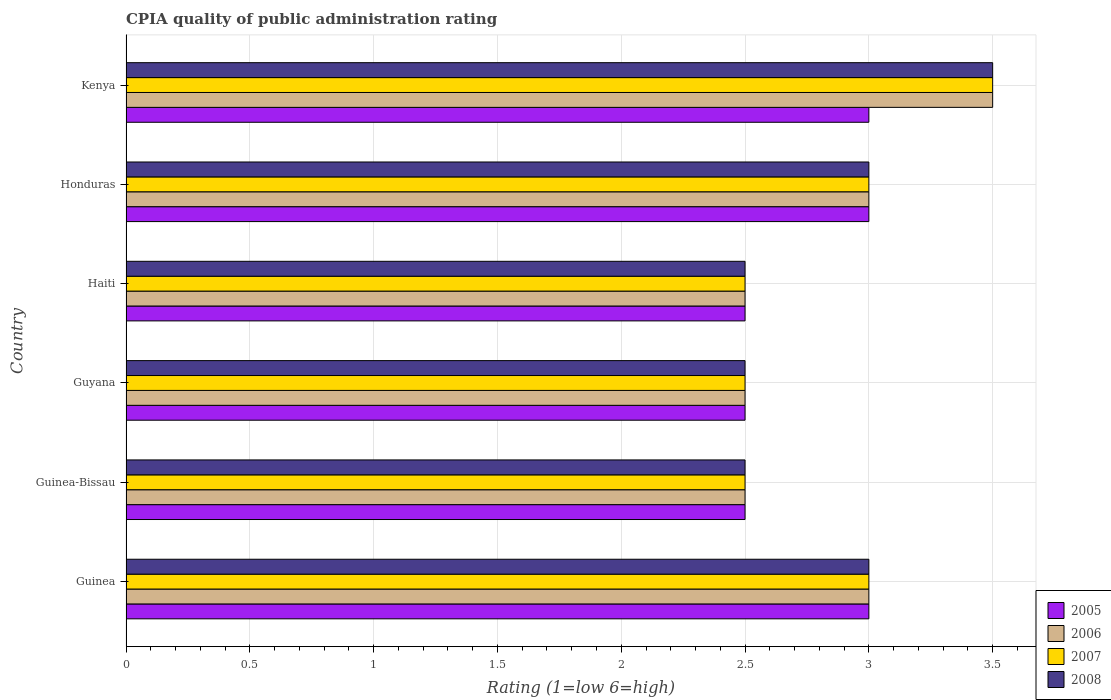How many different coloured bars are there?
Your response must be concise. 4. Are the number of bars per tick equal to the number of legend labels?
Give a very brief answer. Yes. Are the number of bars on each tick of the Y-axis equal?
Your answer should be very brief. Yes. How many bars are there on the 6th tick from the top?
Provide a short and direct response. 4. How many bars are there on the 2nd tick from the bottom?
Your answer should be very brief. 4. What is the label of the 4th group of bars from the top?
Your answer should be very brief. Guyana. In how many cases, is the number of bars for a given country not equal to the number of legend labels?
Your answer should be very brief. 0. What is the CPIA rating in 2007 in Guyana?
Ensure brevity in your answer.  2.5. Across all countries, what is the maximum CPIA rating in 2005?
Offer a very short reply. 3. Across all countries, what is the minimum CPIA rating in 2008?
Ensure brevity in your answer.  2.5. In which country was the CPIA rating in 2005 maximum?
Give a very brief answer. Guinea. In which country was the CPIA rating in 2005 minimum?
Keep it short and to the point. Guinea-Bissau. What is the difference between the CPIA rating in 2007 in Guinea-Bissau and that in Kenya?
Your answer should be compact. -1. What is the average CPIA rating in 2005 per country?
Your answer should be very brief. 2.75. In how many countries, is the CPIA rating in 2007 greater than 0.8 ?
Ensure brevity in your answer.  6. What is the ratio of the CPIA rating in 2008 in Guinea-Bissau to that in Guyana?
Offer a terse response. 1. Is the difference between the CPIA rating in 2005 in Guinea and Haiti greater than the difference between the CPIA rating in 2008 in Guinea and Haiti?
Keep it short and to the point. No. What is the difference between the highest and the lowest CPIA rating in 2008?
Your answer should be compact. 1. In how many countries, is the CPIA rating in 2007 greater than the average CPIA rating in 2007 taken over all countries?
Ensure brevity in your answer.  3. Is the sum of the CPIA rating in 2006 in Guinea and Guyana greater than the maximum CPIA rating in 2008 across all countries?
Offer a terse response. Yes. What does the 2nd bar from the top in Guinea-Bissau represents?
Your answer should be very brief. 2007. What does the 3rd bar from the bottom in Guyana represents?
Your response must be concise. 2007. How many bars are there?
Give a very brief answer. 24. What is the difference between two consecutive major ticks on the X-axis?
Ensure brevity in your answer.  0.5. Are the values on the major ticks of X-axis written in scientific E-notation?
Make the answer very short. No. Does the graph contain any zero values?
Offer a very short reply. No. Does the graph contain grids?
Your response must be concise. Yes. Where does the legend appear in the graph?
Ensure brevity in your answer.  Bottom right. How many legend labels are there?
Offer a terse response. 4. How are the legend labels stacked?
Your answer should be very brief. Vertical. What is the title of the graph?
Offer a very short reply. CPIA quality of public administration rating. Does "1992" appear as one of the legend labels in the graph?
Provide a succinct answer. No. What is the label or title of the X-axis?
Ensure brevity in your answer.  Rating (1=low 6=high). What is the Rating (1=low 6=high) in 2005 in Guinea?
Ensure brevity in your answer.  3. What is the Rating (1=low 6=high) of 2006 in Guinea?
Offer a terse response. 3. What is the Rating (1=low 6=high) of 2008 in Guinea?
Your answer should be compact. 3. What is the Rating (1=low 6=high) of 2005 in Guinea-Bissau?
Offer a very short reply. 2.5. What is the Rating (1=low 6=high) in 2006 in Guyana?
Your answer should be very brief. 2.5. What is the Rating (1=low 6=high) of 2007 in Guyana?
Ensure brevity in your answer.  2.5. What is the Rating (1=low 6=high) in 2006 in Haiti?
Your response must be concise. 2.5. What is the Rating (1=low 6=high) in 2007 in Haiti?
Give a very brief answer. 2.5. What is the Rating (1=low 6=high) of 2008 in Haiti?
Ensure brevity in your answer.  2.5. What is the Rating (1=low 6=high) of 2007 in Honduras?
Make the answer very short. 3. What is the Rating (1=low 6=high) of 2008 in Honduras?
Offer a very short reply. 3. What is the Rating (1=low 6=high) in 2005 in Kenya?
Provide a short and direct response. 3. What is the Rating (1=low 6=high) of 2006 in Kenya?
Your response must be concise. 3.5. Across all countries, what is the maximum Rating (1=low 6=high) of 2005?
Keep it short and to the point. 3. Across all countries, what is the maximum Rating (1=low 6=high) of 2006?
Your response must be concise. 3.5. Across all countries, what is the maximum Rating (1=low 6=high) in 2008?
Your response must be concise. 3.5. Across all countries, what is the minimum Rating (1=low 6=high) of 2007?
Make the answer very short. 2.5. Across all countries, what is the minimum Rating (1=low 6=high) of 2008?
Your response must be concise. 2.5. What is the total Rating (1=low 6=high) in 2007 in the graph?
Your response must be concise. 17. What is the total Rating (1=low 6=high) in 2008 in the graph?
Your answer should be compact. 17. What is the difference between the Rating (1=low 6=high) of 2005 in Guinea and that in Guinea-Bissau?
Provide a short and direct response. 0.5. What is the difference between the Rating (1=low 6=high) in 2007 in Guinea and that in Guinea-Bissau?
Give a very brief answer. 0.5. What is the difference between the Rating (1=low 6=high) in 2008 in Guinea and that in Guinea-Bissau?
Your response must be concise. 0.5. What is the difference between the Rating (1=low 6=high) of 2005 in Guinea and that in Guyana?
Your answer should be very brief. 0.5. What is the difference between the Rating (1=low 6=high) in 2006 in Guinea and that in Guyana?
Ensure brevity in your answer.  0.5. What is the difference between the Rating (1=low 6=high) in 2007 in Guinea and that in Guyana?
Your answer should be very brief. 0.5. What is the difference between the Rating (1=low 6=high) of 2008 in Guinea and that in Guyana?
Your answer should be very brief. 0.5. What is the difference between the Rating (1=low 6=high) of 2005 in Guinea and that in Haiti?
Keep it short and to the point. 0.5. What is the difference between the Rating (1=low 6=high) of 2007 in Guinea and that in Haiti?
Your answer should be compact. 0.5. What is the difference between the Rating (1=low 6=high) of 2008 in Guinea and that in Haiti?
Keep it short and to the point. 0.5. What is the difference between the Rating (1=low 6=high) of 2005 in Guinea and that in Honduras?
Offer a very short reply. 0. What is the difference between the Rating (1=low 6=high) in 2008 in Guinea and that in Honduras?
Offer a terse response. 0. What is the difference between the Rating (1=low 6=high) in 2006 in Guinea and that in Kenya?
Offer a very short reply. -0.5. What is the difference between the Rating (1=low 6=high) of 2005 in Guinea-Bissau and that in Guyana?
Ensure brevity in your answer.  0. What is the difference between the Rating (1=low 6=high) of 2006 in Guinea-Bissau and that in Guyana?
Offer a very short reply. 0. What is the difference between the Rating (1=low 6=high) of 2008 in Guinea-Bissau and that in Guyana?
Your answer should be very brief. 0. What is the difference between the Rating (1=low 6=high) in 2006 in Guinea-Bissau and that in Haiti?
Give a very brief answer. 0. What is the difference between the Rating (1=low 6=high) of 2007 in Guinea-Bissau and that in Haiti?
Offer a terse response. 0. What is the difference between the Rating (1=low 6=high) in 2005 in Guinea-Bissau and that in Honduras?
Provide a short and direct response. -0.5. What is the difference between the Rating (1=low 6=high) in 2007 in Guinea-Bissau and that in Honduras?
Offer a terse response. -0.5. What is the difference between the Rating (1=low 6=high) of 2008 in Guinea-Bissau and that in Honduras?
Your response must be concise. -0.5. What is the difference between the Rating (1=low 6=high) in 2005 in Guinea-Bissau and that in Kenya?
Your response must be concise. -0.5. What is the difference between the Rating (1=low 6=high) in 2008 in Guinea-Bissau and that in Kenya?
Provide a short and direct response. -1. What is the difference between the Rating (1=low 6=high) of 2006 in Guyana and that in Haiti?
Give a very brief answer. 0. What is the difference between the Rating (1=low 6=high) in 2007 in Guyana and that in Haiti?
Offer a terse response. 0. What is the difference between the Rating (1=low 6=high) in 2005 in Guyana and that in Honduras?
Offer a terse response. -0.5. What is the difference between the Rating (1=low 6=high) of 2006 in Guyana and that in Honduras?
Your answer should be very brief. -0.5. What is the difference between the Rating (1=low 6=high) in 2007 in Guyana and that in Honduras?
Keep it short and to the point. -0.5. What is the difference between the Rating (1=low 6=high) of 2008 in Guyana and that in Honduras?
Keep it short and to the point. -0.5. What is the difference between the Rating (1=low 6=high) in 2005 in Guyana and that in Kenya?
Make the answer very short. -0.5. What is the difference between the Rating (1=low 6=high) in 2006 in Haiti and that in Honduras?
Keep it short and to the point. -0.5. What is the difference between the Rating (1=low 6=high) in 2007 in Haiti and that in Honduras?
Your response must be concise. -0.5. What is the difference between the Rating (1=low 6=high) in 2008 in Haiti and that in Honduras?
Provide a short and direct response. -0.5. What is the difference between the Rating (1=low 6=high) of 2006 in Haiti and that in Kenya?
Keep it short and to the point. -1. What is the difference between the Rating (1=low 6=high) of 2005 in Honduras and that in Kenya?
Keep it short and to the point. 0. What is the difference between the Rating (1=low 6=high) of 2007 in Honduras and that in Kenya?
Provide a short and direct response. -0.5. What is the difference between the Rating (1=low 6=high) in 2005 in Guinea and the Rating (1=low 6=high) in 2006 in Guinea-Bissau?
Keep it short and to the point. 0.5. What is the difference between the Rating (1=low 6=high) in 2005 in Guinea and the Rating (1=low 6=high) in 2008 in Guinea-Bissau?
Provide a short and direct response. 0.5. What is the difference between the Rating (1=low 6=high) of 2006 in Guinea and the Rating (1=low 6=high) of 2007 in Guinea-Bissau?
Offer a terse response. 0.5. What is the difference between the Rating (1=low 6=high) of 2006 in Guinea and the Rating (1=low 6=high) of 2008 in Guinea-Bissau?
Make the answer very short. 0.5. What is the difference between the Rating (1=low 6=high) in 2005 in Guinea and the Rating (1=low 6=high) in 2006 in Guyana?
Make the answer very short. 0.5. What is the difference between the Rating (1=low 6=high) in 2005 in Guinea and the Rating (1=low 6=high) in 2007 in Guyana?
Your answer should be compact. 0.5. What is the difference between the Rating (1=low 6=high) in 2005 in Guinea and the Rating (1=low 6=high) in 2008 in Guyana?
Your answer should be very brief. 0.5. What is the difference between the Rating (1=low 6=high) of 2006 in Guinea and the Rating (1=low 6=high) of 2008 in Guyana?
Your answer should be compact. 0.5. What is the difference between the Rating (1=low 6=high) of 2005 in Guinea and the Rating (1=low 6=high) of 2006 in Haiti?
Ensure brevity in your answer.  0.5. What is the difference between the Rating (1=low 6=high) of 2005 in Guinea and the Rating (1=low 6=high) of 2007 in Haiti?
Offer a terse response. 0.5. What is the difference between the Rating (1=low 6=high) of 2005 in Guinea and the Rating (1=low 6=high) of 2006 in Honduras?
Keep it short and to the point. 0. What is the difference between the Rating (1=low 6=high) in 2005 in Guinea and the Rating (1=low 6=high) in 2007 in Honduras?
Provide a succinct answer. 0. What is the difference between the Rating (1=low 6=high) in 2005 in Guinea and the Rating (1=low 6=high) in 2008 in Honduras?
Keep it short and to the point. 0. What is the difference between the Rating (1=low 6=high) of 2006 in Guinea and the Rating (1=low 6=high) of 2007 in Honduras?
Your answer should be compact. 0. What is the difference between the Rating (1=low 6=high) in 2006 in Guinea and the Rating (1=low 6=high) in 2008 in Honduras?
Give a very brief answer. 0. What is the difference between the Rating (1=low 6=high) of 2005 in Guinea and the Rating (1=low 6=high) of 2006 in Kenya?
Your answer should be very brief. -0.5. What is the difference between the Rating (1=low 6=high) of 2005 in Guinea and the Rating (1=low 6=high) of 2007 in Kenya?
Keep it short and to the point. -0.5. What is the difference between the Rating (1=low 6=high) of 2007 in Guinea and the Rating (1=low 6=high) of 2008 in Kenya?
Give a very brief answer. -0.5. What is the difference between the Rating (1=low 6=high) of 2005 in Guinea-Bissau and the Rating (1=low 6=high) of 2007 in Guyana?
Your response must be concise. 0. What is the difference between the Rating (1=low 6=high) in 2005 in Guinea-Bissau and the Rating (1=low 6=high) in 2008 in Guyana?
Provide a short and direct response. 0. What is the difference between the Rating (1=low 6=high) of 2006 in Guinea-Bissau and the Rating (1=low 6=high) of 2007 in Guyana?
Offer a very short reply. 0. What is the difference between the Rating (1=low 6=high) of 2005 in Guinea-Bissau and the Rating (1=low 6=high) of 2007 in Haiti?
Offer a very short reply. 0. What is the difference between the Rating (1=low 6=high) of 2007 in Guinea-Bissau and the Rating (1=low 6=high) of 2008 in Haiti?
Make the answer very short. 0. What is the difference between the Rating (1=low 6=high) in 2005 in Guinea-Bissau and the Rating (1=low 6=high) in 2006 in Honduras?
Your response must be concise. -0.5. What is the difference between the Rating (1=low 6=high) of 2005 in Guinea-Bissau and the Rating (1=low 6=high) of 2008 in Honduras?
Offer a terse response. -0.5. What is the difference between the Rating (1=low 6=high) of 2006 in Guinea-Bissau and the Rating (1=low 6=high) of 2007 in Honduras?
Your answer should be very brief. -0.5. What is the difference between the Rating (1=low 6=high) in 2007 in Guinea-Bissau and the Rating (1=low 6=high) in 2008 in Honduras?
Provide a succinct answer. -0.5. What is the difference between the Rating (1=low 6=high) in 2005 in Guinea-Bissau and the Rating (1=low 6=high) in 2006 in Kenya?
Provide a succinct answer. -1. What is the difference between the Rating (1=low 6=high) in 2005 in Guinea-Bissau and the Rating (1=low 6=high) in 2007 in Kenya?
Your answer should be very brief. -1. What is the difference between the Rating (1=low 6=high) of 2005 in Guinea-Bissau and the Rating (1=low 6=high) of 2008 in Kenya?
Your answer should be compact. -1. What is the difference between the Rating (1=low 6=high) in 2006 in Guinea-Bissau and the Rating (1=low 6=high) in 2008 in Kenya?
Make the answer very short. -1. What is the difference between the Rating (1=low 6=high) in 2007 in Guinea-Bissau and the Rating (1=low 6=high) in 2008 in Kenya?
Give a very brief answer. -1. What is the difference between the Rating (1=low 6=high) of 2005 in Guyana and the Rating (1=low 6=high) of 2006 in Haiti?
Offer a very short reply. 0. What is the difference between the Rating (1=low 6=high) in 2005 in Guyana and the Rating (1=low 6=high) in 2007 in Haiti?
Give a very brief answer. 0. What is the difference between the Rating (1=low 6=high) in 2005 in Guyana and the Rating (1=low 6=high) in 2008 in Haiti?
Provide a succinct answer. 0. What is the difference between the Rating (1=low 6=high) of 2006 in Guyana and the Rating (1=low 6=high) of 2008 in Haiti?
Provide a succinct answer. 0. What is the difference between the Rating (1=low 6=high) in 2007 in Guyana and the Rating (1=low 6=high) in 2008 in Haiti?
Ensure brevity in your answer.  0. What is the difference between the Rating (1=low 6=high) in 2006 in Guyana and the Rating (1=low 6=high) in 2008 in Honduras?
Your answer should be very brief. -0.5. What is the difference between the Rating (1=low 6=high) in 2007 in Guyana and the Rating (1=low 6=high) in 2008 in Honduras?
Provide a short and direct response. -0.5. What is the difference between the Rating (1=low 6=high) of 2005 in Guyana and the Rating (1=low 6=high) of 2007 in Kenya?
Your answer should be compact. -1. What is the difference between the Rating (1=low 6=high) in 2005 in Guyana and the Rating (1=low 6=high) in 2008 in Kenya?
Give a very brief answer. -1. What is the difference between the Rating (1=low 6=high) of 2006 in Guyana and the Rating (1=low 6=high) of 2007 in Kenya?
Your answer should be very brief. -1. What is the difference between the Rating (1=low 6=high) in 2007 in Guyana and the Rating (1=low 6=high) in 2008 in Kenya?
Give a very brief answer. -1. What is the difference between the Rating (1=low 6=high) in 2005 in Haiti and the Rating (1=low 6=high) in 2006 in Honduras?
Provide a short and direct response. -0.5. What is the difference between the Rating (1=low 6=high) of 2006 in Haiti and the Rating (1=low 6=high) of 2007 in Honduras?
Give a very brief answer. -0.5. What is the difference between the Rating (1=low 6=high) in 2007 in Haiti and the Rating (1=low 6=high) in 2008 in Honduras?
Your response must be concise. -0.5. What is the difference between the Rating (1=low 6=high) in 2005 in Haiti and the Rating (1=low 6=high) in 2007 in Kenya?
Give a very brief answer. -1. What is the difference between the Rating (1=low 6=high) of 2005 in Haiti and the Rating (1=low 6=high) of 2008 in Kenya?
Offer a terse response. -1. What is the difference between the Rating (1=low 6=high) of 2005 in Honduras and the Rating (1=low 6=high) of 2006 in Kenya?
Make the answer very short. -0.5. What is the difference between the Rating (1=low 6=high) in 2005 in Honduras and the Rating (1=low 6=high) in 2007 in Kenya?
Offer a very short reply. -0.5. What is the difference between the Rating (1=low 6=high) of 2005 in Honduras and the Rating (1=low 6=high) of 2008 in Kenya?
Keep it short and to the point. -0.5. What is the difference between the Rating (1=low 6=high) of 2006 in Honduras and the Rating (1=low 6=high) of 2008 in Kenya?
Give a very brief answer. -0.5. What is the difference between the Rating (1=low 6=high) in 2007 in Honduras and the Rating (1=low 6=high) in 2008 in Kenya?
Your answer should be compact. -0.5. What is the average Rating (1=low 6=high) of 2005 per country?
Make the answer very short. 2.75. What is the average Rating (1=low 6=high) of 2006 per country?
Keep it short and to the point. 2.83. What is the average Rating (1=low 6=high) of 2007 per country?
Your answer should be compact. 2.83. What is the average Rating (1=low 6=high) in 2008 per country?
Make the answer very short. 2.83. What is the difference between the Rating (1=low 6=high) of 2005 and Rating (1=low 6=high) of 2006 in Guinea?
Provide a short and direct response. 0. What is the difference between the Rating (1=low 6=high) in 2005 and Rating (1=low 6=high) in 2007 in Guinea?
Give a very brief answer. 0. What is the difference between the Rating (1=low 6=high) of 2005 and Rating (1=low 6=high) of 2008 in Guinea?
Provide a succinct answer. 0. What is the difference between the Rating (1=low 6=high) of 2006 and Rating (1=low 6=high) of 2007 in Guinea?
Your response must be concise. 0. What is the difference between the Rating (1=low 6=high) of 2005 and Rating (1=low 6=high) of 2006 in Guinea-Bissau?
Provide a succinct answer. 0. What is the difference between the Rating (1=low 6=high) of 2005 and Rating (1=low 6=high) of 2007 in Guinea-Bissau?
Your answer should be compact. 0. What is the difference between the Rating (1=low 6=high) of 2005 and Rating (1=low 6=high) of 2008 in Guinea-Bissau?
Your response must be concise. 0. What is the difference between the Rating (1=low 6=high) of 2006 and Rating (1=low 6=high) of 2007 in Guinea-Bissau?
Your response must be concise. 0. What is the difference between the Rating (1=low 6=high) of 2006 and Rating (1=low 6=high) of 2008 in Guinea-Bissau?
Your response must be concise. 0. What is the difference between the Rating (1=low 6=high) of 2005 and Rating (1=low 6=high) of 2006 in Guyana?
Keep it short and to the point. 0. What is the difference between the Rating (1=low 6=high) of 2005 and Rating (1=low 6=high) of 2007 in Guyana?
Your answer should be very brief. 0. What is the difference between the Rating (1=low 6=high) in 2006 and Rating (1=low 6=high) in 2008 in Guyana?
Offer a very short reply. 0. What is the difference between the Rating (1=low 6=high) of 2007 and Rating (1=low 6=high) of 2008 in Guyana?
Ensure brevity in your answer.  0. What is the difference between the Rating (1=low 6=high) in 2005 and Rating (1=low 6=high) in 2008 in Haiti?
Keep it short and to the point. 0. What is the difference between the Rating (1=low 6=high) of 2006 and Rating (1=low 6=high) of 2007 in Haiti?
Provide a short and direct response. 0. What is the difference between the Rating (1=low 6=high) in 2005 and Rating (1=low 6=high) in 2006 in Honduras?
Provide a succinct answer. 0. What is the difference between the Rating (1=low 6=high) in 2005 and Rating (1=low 6=high) in 2007 in Honduras?
Your response must be concise. 0. What is the difference between the Rating (1=low 6=high) of 2005 and Rating (1=low 6=high) of 2008 in Honduras?
Your answer should be very brief. 0. What is the difference between the Rating (1=low 6=high) of 2007 and Rating (1=low 6=high) of 2008 in Honduras?
Give a very brief answer. 0. What is the difference between the Rating (1=low 6=high) of 2005 and Rating (1=low 6=high) of 2006 in Kenya?
Ensure brevity in your answer.  -0.5. What is the difference between the Rating (1=low 6=high) in 2005 and Rating (1=low 6=high) in 2007 in Kenya?
Your answer should be compact. -0.5. What is the difference between the Rating (1=low 6=high) in 2006 and Rating (1=low 6=high) in 2008 in Kenya?
Your answer should be very brief. 0. What is the difference between the Rating (1=low 6=high) in 2007 and Rating (1=low 6=high) in 2008 in Kenya?
Ensure brevity in your answer.  0. What is the ratio of the Rating (1=low 6=high) in 2007 in Guinea to that in Guinea-Bissau?
Keep it short and to the point. 1.2. What is the ratio of the Rating (1=low 6=high) of 2008 in Guinea to that in Guinea-Bissau?
Ensure brevity in your answer.  1.2. What is the ratio of the Rating (1=low 6=high) of 2006 in Guinea to that in Guyana?
Keep it short and to the point. 1.2. What is the ratio of the Rating (1=low 6=high) in 2006 in Guinea to that in Haiti?
Make the answer very short. 1.2. What is the ratio of the Rating (1=low 6=high) in 2007 in Guinea to that in Haiti?
Your answer should be compact. 1.2. What is the ratio of the Rating (1=low 6=high) of 2008 in Guinea to that in Haiti?
Ensure brevity in your answer.  1.2. What is the ratio of the Rating (1=low 6=high) in 2005 in Guinea to that in Honduras?
Keep it short and to the point. 1. What is the ratio of the Rating (1=low 6=high) in 2006 in Guinea to that in Honduras?
Keep it short and to the point. 1. What is the ratio of the Rating (1=low 6=high) of 2007 in Guinea to that in Honduras?
Give a very brief answer. 1. What is the ratio of the Rating (1=low 6=high) in 2005 in Guinea to that in Kenya?
Provide a succinct answer. 1. What is the ratio of the Rating (1=low 6=high) in 2007 in Guinea-Bissau to that in Guyana?
Ensure brevity in your answer.  1. What is the ratio of the Rating (1=low 6=high) of 2005 in Guinea-Bissau to that in Haiti?
Ensure brevity in your answer.  1. What is the ratio of the Rating (1=low 6=high) in 2007 in Guinea-Bissau to that in Haiti?
Your answer should be compact. 1. What is the ratio of the Rating (1=low 6=high) of 2008 in Guinea-Bissau to that in Haiti?
Provide a succinct answer. 1. What is the ratio of the Rating (1=low 6=high) of 2005 in Guinea-Bissau to that in Honduras?
Keep it short and to the point. 0.83. What is the ratio of the Rating (1=low 6=high) of 2006 in Guinea-Bissau to that in Honduras?
Provide a succinct answer. 0.83. What is the ratio of the Rating (1=low 6=high) of 2008 in Guinea-Bissau to that in Honduras?
Offer a terse response. 0.83. What is the ratio of the Rating (1=low 6=high) in 2005 in Guinea-Bissau to that in Kenya?
Offer a terse response. 0.83. What is the ratio of the Rating (1=low 6=high) in 2006 in Guinea-Bissau to that in Kenya?
Ensure brevity in your answer.  0.71. What is the ratio of the Rating (1=low 6=high) in 2007 in Guinea-Bissau to that in Kenya?
Give a very brief answer. 0.71. What is the ratio of the Rating (1=low 6=high) of 2008 in Guinea-Bissau to that in Kenya?
Give a very brief answer. 0.71. What is the ratio of the Rating (1=low 6=high) of 2008 in Guyana to that in Haiti?
Offer a very short reply. 1. What is the ratio of the Rating (1=low 6=high) in 2005 in Guyana to that in Honduras?
Offer a terse response. 0.83. What is the ratio of the Rating (1=low 6=high) in 2006 in Guyana to that in Honduras?
Give a very brief answer. 0.83. What is the ratio of the Rating (1=low 6=high) in 2008 in Guyana to that in Honduras?
Ensure brevity in your answer.  0.83. What is the ratio of the Rating (1=low 6=high) of 2005 in Guyana to that in Kenya?
Provide a short and direct response. 0.83. What is the ratio of the Rating (1=low 6=high) in 2006 in Guyana to that in Kenya?
Your answer should be very brief. 0.71. What is the ratio of the Rating (1=low 6=high) of 2007 in Guyana to that in Kenya?
Your answer should be compact. 0.71. What is the ratio of the Rating (1=low 6=high) in 2008 in Haiti to that in Honduras?
Your answer should be very brief. 0.83. What is the ratio of the Rating (1=low 6=high) in 2005 in Haiti to that in Kenya?
Make the answer very short. 0.83. What is the ratio of the Rating (1=low 6=high) of 2006 in Haiti to that in Kenya?
Offer a very short reply. 0.71. What is the ratio of the Rating (1=low 6=high) of 2007 in Haiti to that in Kenya?
Make the answer very short. 0.71. What is the ratio of the Rating (1=low 6=high) in 2008 in Haiti to that in Kenya?
Your answer should be compact. 0.71. What is the ratio of the Rating (1=low 6=high) of 2006 in Honduras to that in Kenya?
Your answer should be compact. 0.86. What is the ratio of the Rating (1=low 6=high) of 2007 in Honduras to that in Kenya?
Your answer should be very brief. 0.86. What is the ratio of the Rating (1=low 6=high) in 2008 in Honduras to that in Kenya?
Give a very brief answer. 0.86. What is the difference between the highest and the second highest Rating (1=low 6=high) of 2006?
Your response must be concise. 0.5. What is the difference between the highest and the second highest Rating (1=low 6=high) in 2007?
Provide a short and direct response. 0.5. What is the difference between the highest and the lowest Rating (1=low 6=high) of 2007?
Provide a succinct answer. 1. What is the difference between the highest and the lowest Rating (1=low 6=high) in 2008?
Keep it short and to the point. 1. 